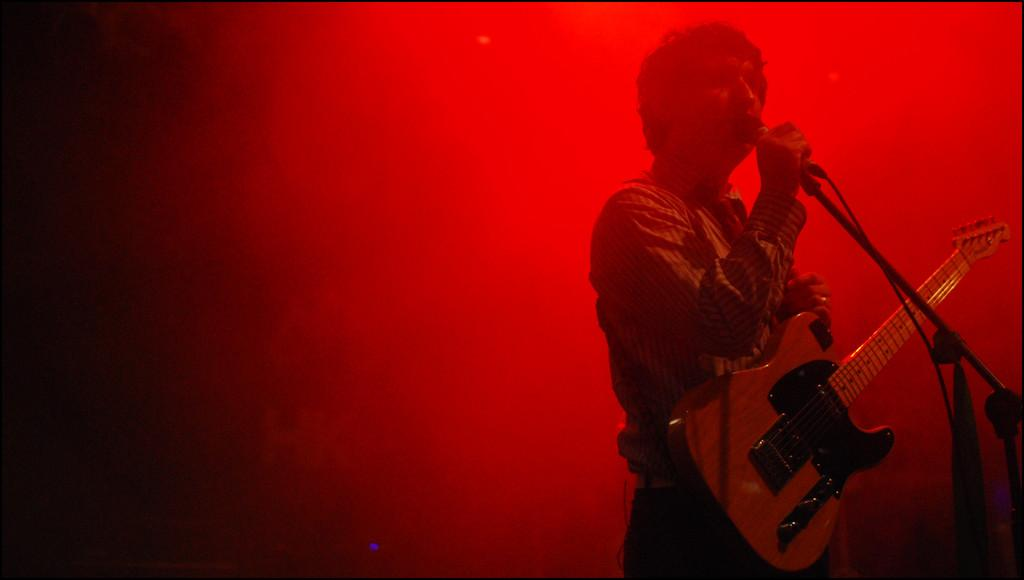What is the main subject of the image? The main subject of the image is a man. What is the man doing in the image? The man is standing in front of a microphone. What object is the man holding in the image? The man is holding a guitar. What type of expansion is the man performing in the image? There is no expansion being performed in the image; the man is simply standing in front of a microphone and holding a guitar. Can you see a cap on the man's head in the image? There is no mention of a cap in the provided facts, so it cannot be determined whether the man is wearing a cap or not. 